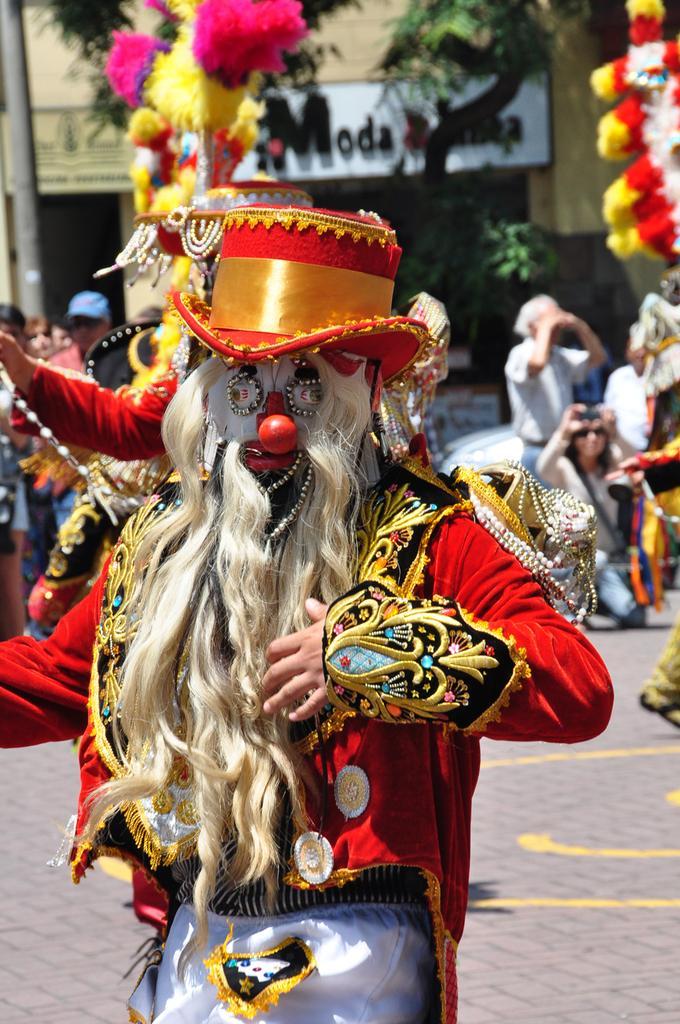Could you give a brief overview of what you see in this image? In the center of the image we can see a person with costumes. In the background we can see persons, trees, pole and building. 